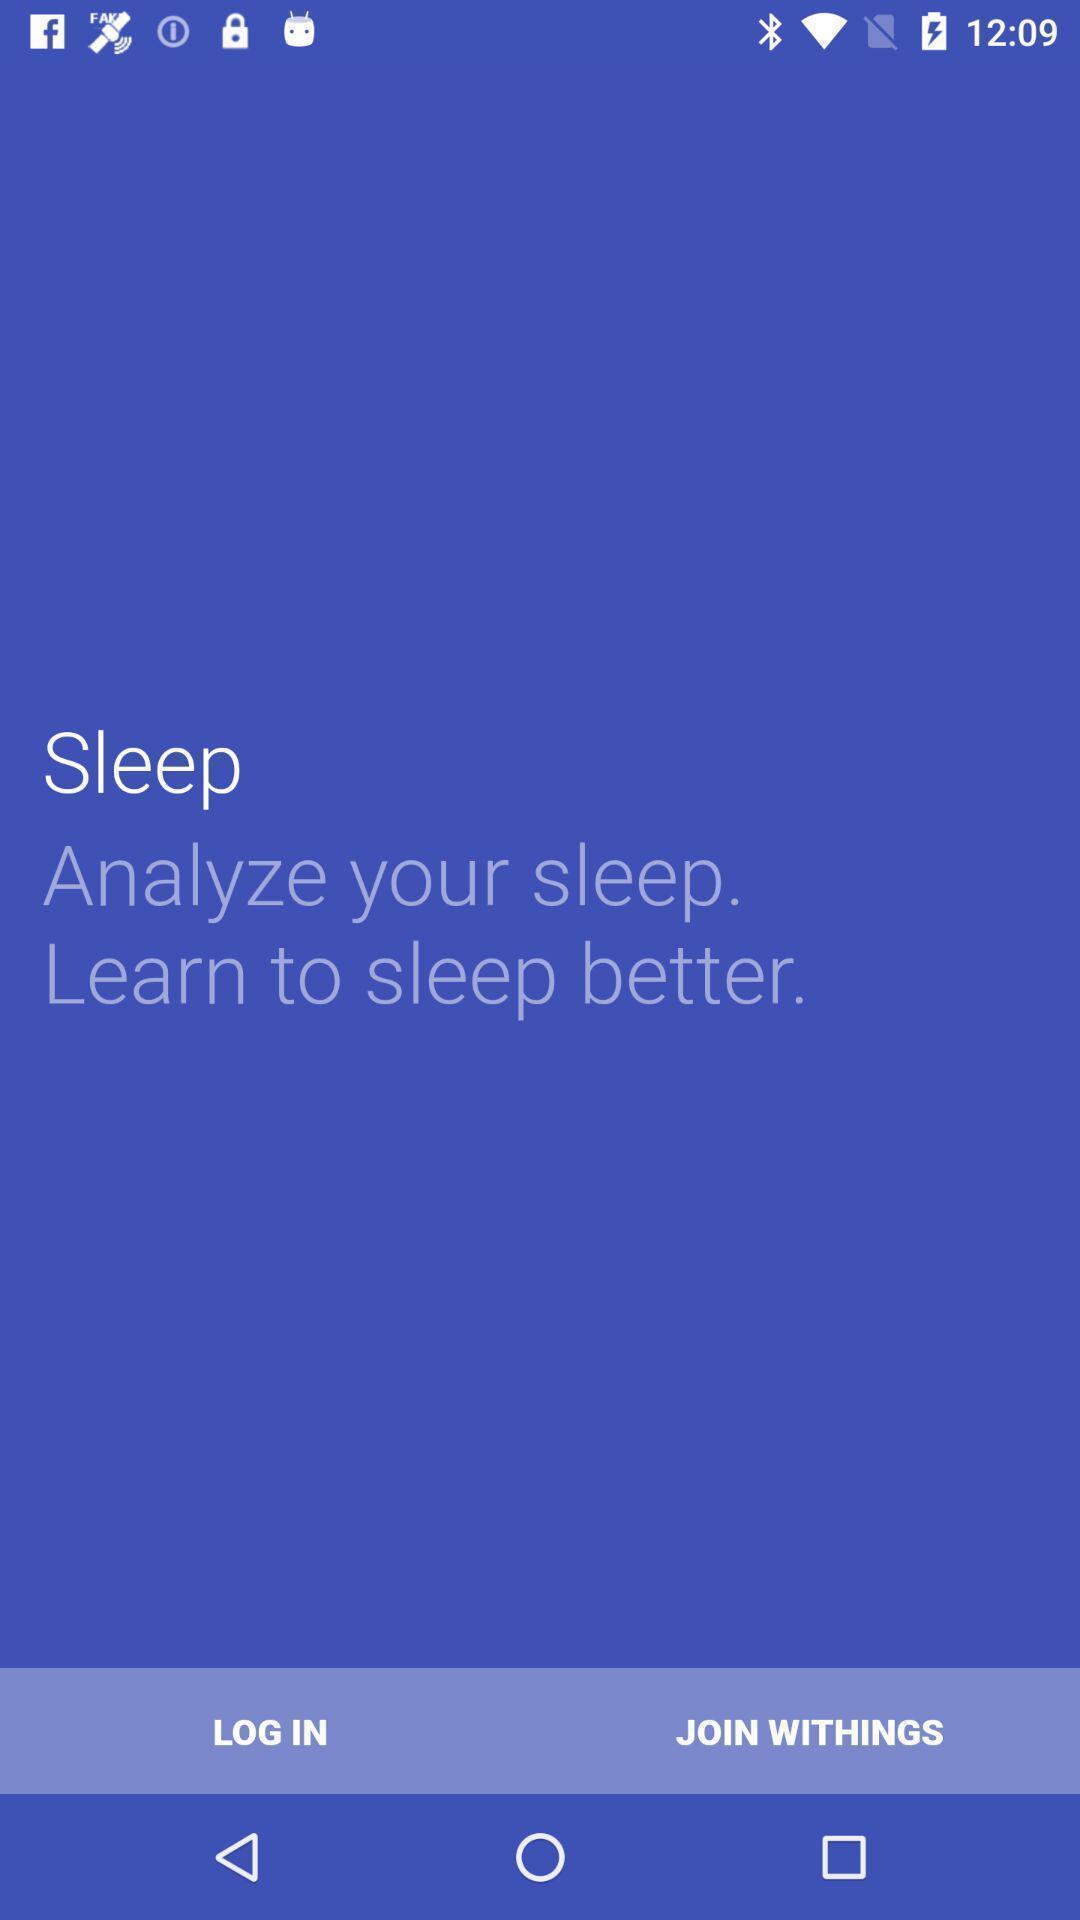Tell me what you see in this picture. Welcome page of a sleep tracker. 